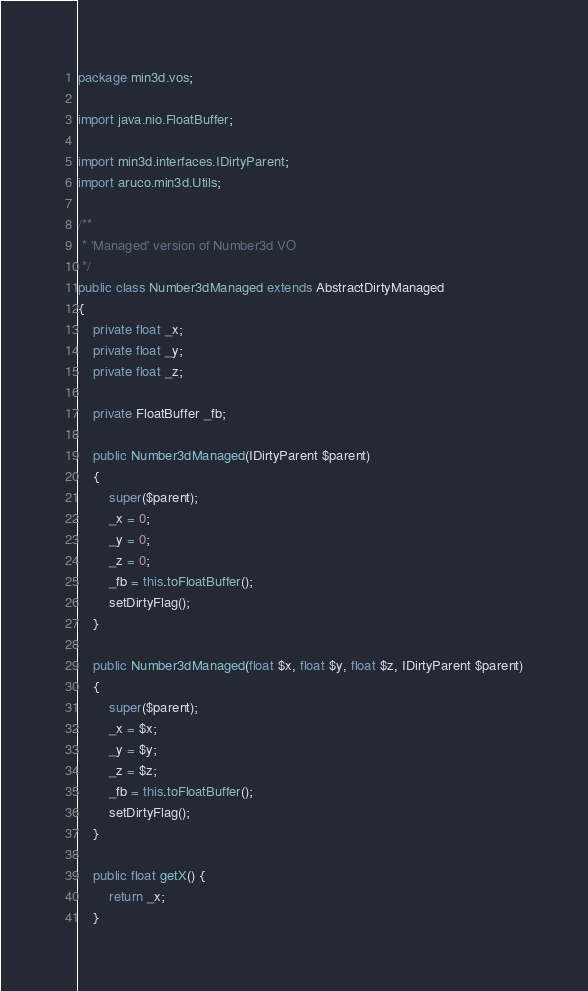Convert code to text. <code><loc_0><loc_0><loc_500><loc_500><_Java_>package min3d.vos;

import java.nio.FloatBuffer;

import min3d.interfaces.IDirtyParent;
import aruco.min3d.Utils;

/**
 * 'Managed' version of Number3d VO 
 */
public class Number3dManaged extends AbstractDirtyManaged 
{
	private float _x;
	private float _y;
	private float _z;
	
	private FloatBuffer _fb;
	
	public Number3dManaged(IDirtyParent $parent)
	{
		super($parent);
		_x = 0;
		_y = 0;
		_z = 0;
		_fb = this.toFloatBuffer();
		setDirtyFlag();
	}
	
	public Number3dManaged(float $x, float $y, float $z, IDirtyParent $parent)
	{
		super($parent);
		_x = $x;
		_y = $y;
		_z = $z;
		_fb = this.toFloatBuffer();
		setDirtyFlag();
	}
	
	public float getX() {
		return _x;
	}
</code> 